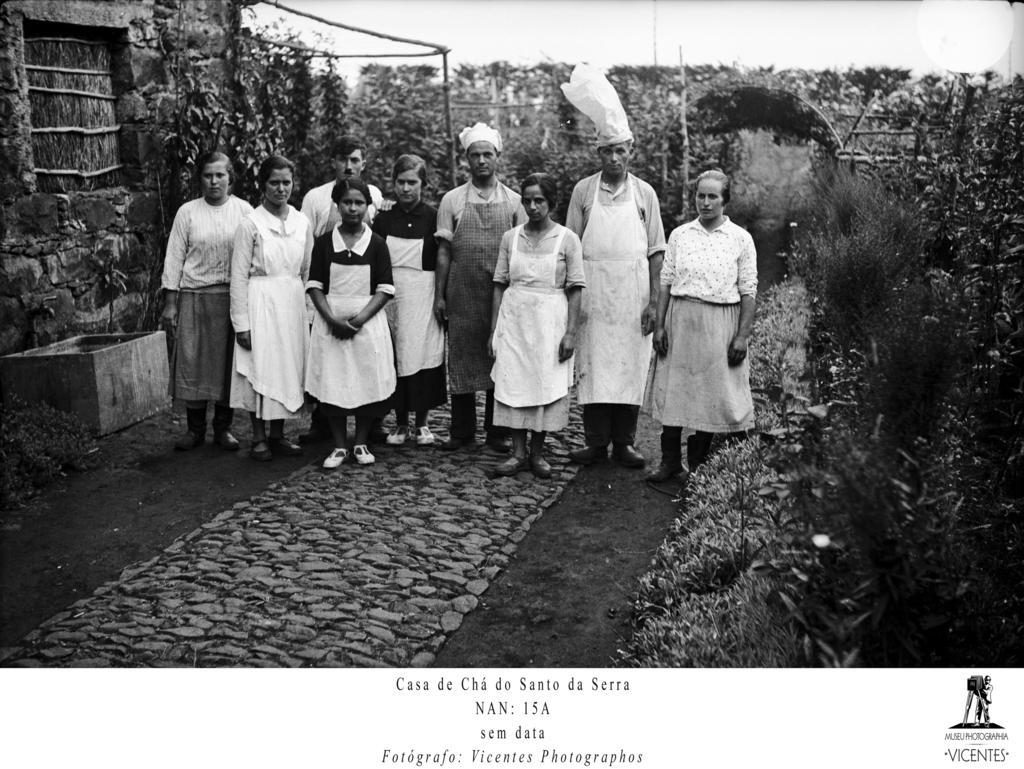In one or two sentences, can you explain what this image depicts? In this image, there are some people standing in the middle, and we can see there are some trees surrounded. 